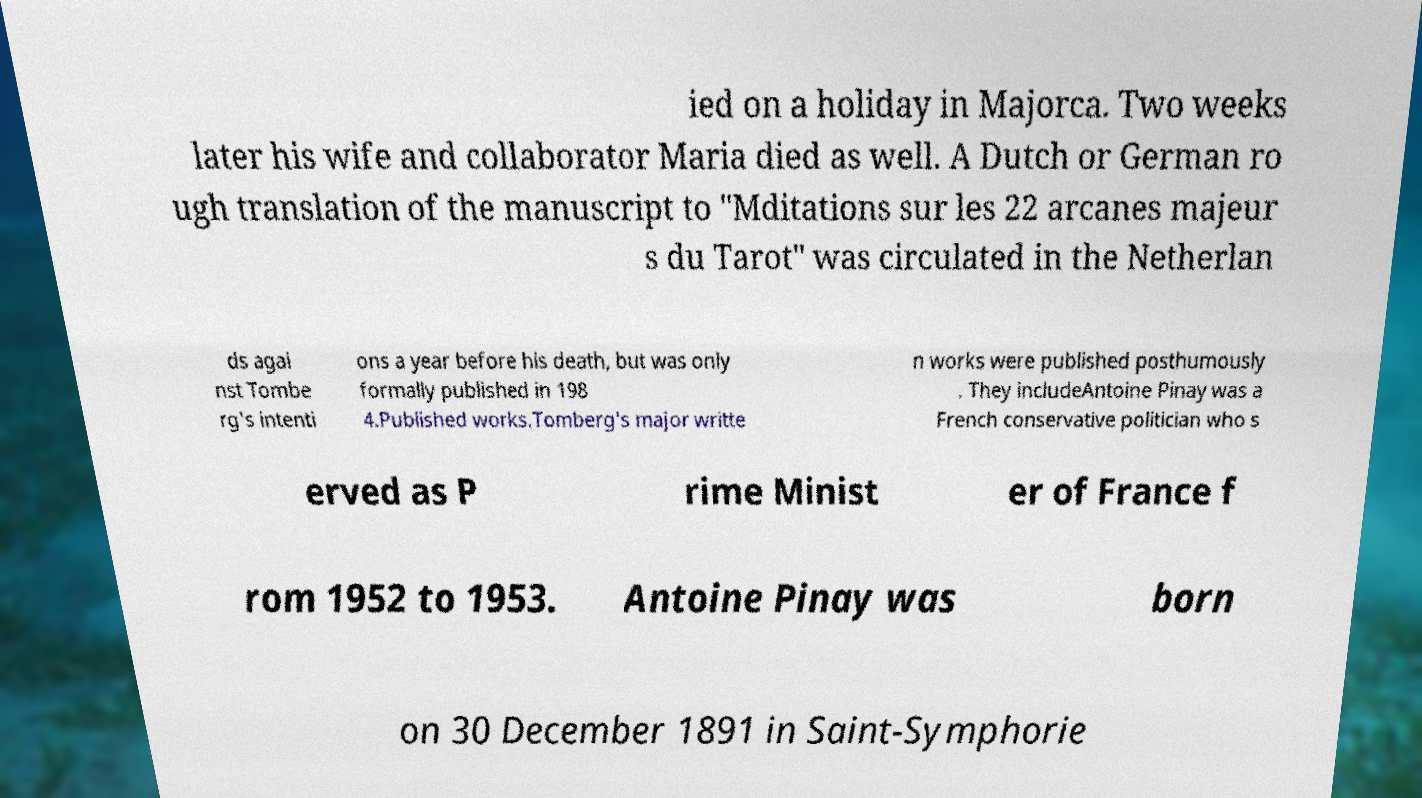For documentation purposes, I need the text within this image transcribed. Could you provide that? ied on a holiday in Majorca. Two weeks later his wife and collaborator Maria died as well. A Dutch or German ro ugh translation of the manuscript to "Mditations sur les 22 arcanes majeur s du Tarot" was circulated in the Netherlan ds agai nst Tombe rg's intenti ons a year before his death, but was only formally published in 198 4.Published works.Tomberg's major writte n works were published posthumously . They includeAntoine Pinay was a French conservative politician who s erved as P rime Minist er of France f rom 1952 to 1953. Antoine Pinay was born on 30 December 1891 in Saint-Symphorie 